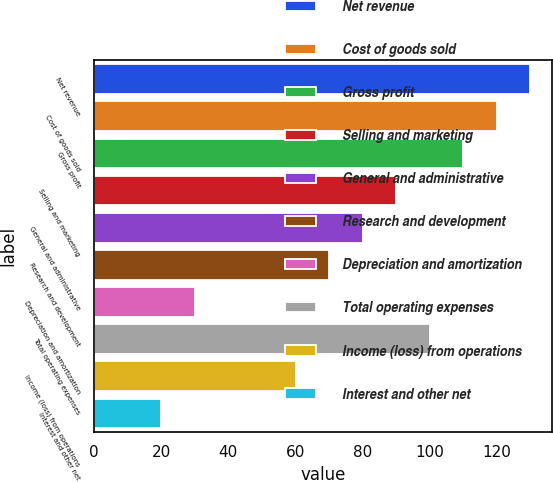Convert chart to OTSL. <chart><loc_0><loc_0><loc_500><loc_500><bar_chart><fcel>Net revenue<fcel>Cost of goods sold<fcel>Gross profit<fcel>Selling and marketing<fcel>General and administrative<fcel>Research and development<fcel>Depreciation and amortization<fcel>Total operating expenses<fcel>Income (loss) from operations<fcel>Interest and other net<nl><fcel>129.97<fcel>119.98<fcel>109.99<fcel>90.01<fcel>80.02<fcel>70.03<fcel>30.07<fcel>100<fcel>60.04<fcel>20.08<nl></chart> 